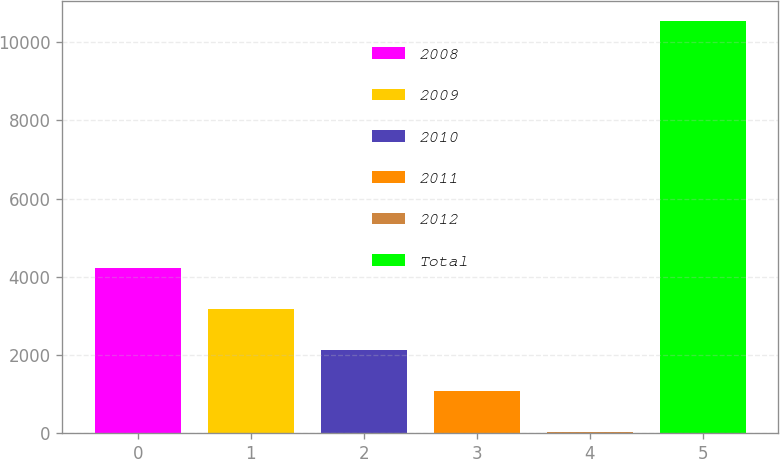Convert chart to OTSL. <chart><loc_0><loc_0><loc_500><loc_500><bar_chart><fcel>2008<fcel>2009<fcel>2010<fcel>2011<fcel>2012<fcel>Total<nl><fcel>4226.4<fcel>3176.3<fcel>2126.2<fcel>1076.1<fcel>26<fcel>10527<nl></chart> 